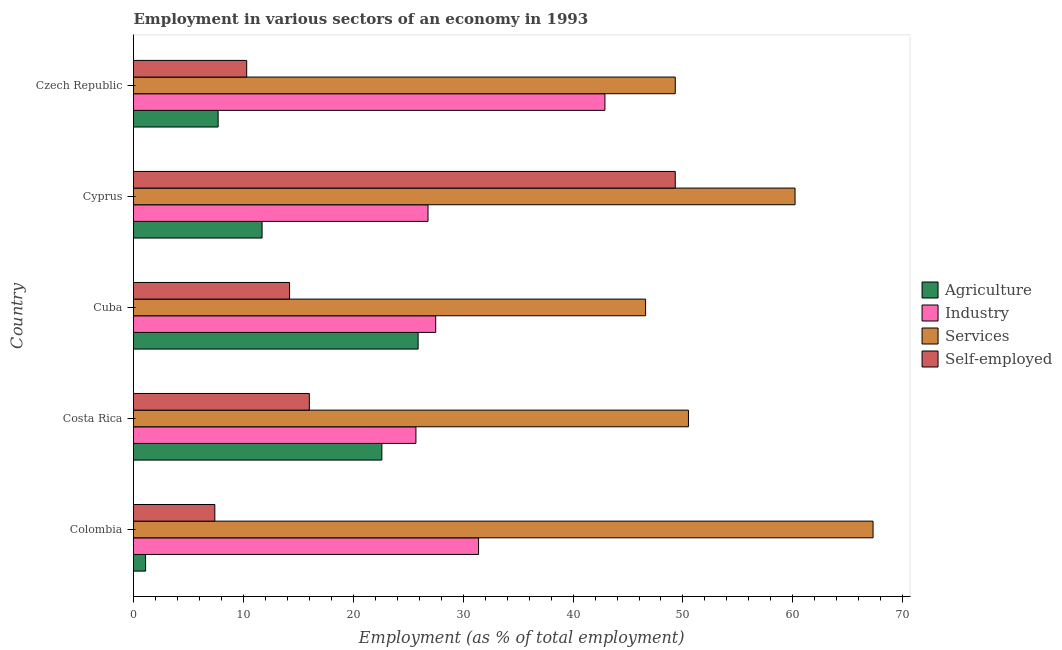How many different coloured bars are there?
Offer a very short reply. 4. Are the number of bars per tick equal to the number of legend labels?
Make the answer very short. Yes. Are the number of bars on each tick of the Y-axis equal?
Give a very brief answer. Yes. How many bars are there on the 3rd tick from the top?
Provide a short and direct response. 4. How many bars are there on the 2nd tick from the bottom?
Offer a terse response. 4. What is the label of the 3rd group of bars from the top?
Your response must be concise. Cuba. In how many cases, is the number of bars for a given country not equal to the number of legend labels?
Give a very brief answer. 0. What is the percentage of workers in services in Czech Republic?
Keep it short and to the point. 49.3. Across all countries, what is the maximum percentage of self employed workers?
Give a very brief answer. 49.3. Across all countries, what is the minimum percentage of workers in services?
Provide a short and direct response. 46.6. In which country was the percentage of workers in industry minimum?
Your response must be concise. Costa Rica. What is the total percentage of self employed workers in the graph?
Your answer should be very brief. 97.2. What is the difference between the percentage of self employed workers in Czech Republic and the percentage of workers in agriculture in Cyprus?
Your answer should be compact. -1.4. What is the average percentage of self employed workers per country?
Offer a terse response. 19.44. What is the difference between the percentage of self employed workers and percentage of workers in services in Cuba?
Make the answer very short. -32.4. What is the ratio of the percentage of workers in agriculture in Colombia to that in Czech Republic?
Offer a terse response. 0.14. Is the percentage of self employed workers in Cuba less than that in Czech Republic?
Offer a very short reply. No. What is the difference between the highest and the lowest percentage of workers in services?
Your answer should be compact. 20.7. In how many countries, is the percentage of workers in services greater than the average percentage of workers in services taken over all countries?
Provide a short and direct response. 2. Is the sum of the percentage of self employed workers in Colombia and Costa Rica greater than the maximum percentage of workers in industry across all countries?
Keep it short and to the point. No. What does the 2nd bar from the top in Czech Republic represents?
Ensure brevity in your answer.  Services. What does the 1st bar from the bottom in Cuba represents?
Make the answer very short. Agriculture. Is it the case that in every country, the sum of the percentage of workers in agriculture and percentage of workers in industry is greater than the percentage of workers in services?
Your answer should be compact. No. What is the difference between two consecutive major ticks on the X-axis?
Your answer should be very brief. 10. Where does the legend appear in the graph?
Offer a very short reply. Center right. What is the title of the graph?
Your answer should be very brief. Employment in various sectors of an economy in 1993. Does "Periodicity assessment" appear as one of the legend labels in the graph?
Provide a succinct answer. No. What is the label or title of the X-axis?
Give a very brief answer. Employment (as % of total employment). What is the label or title of the Y-axis?
Provide a short and direct response. Country. What is the Employment (as % of total employment) in Agriculture in Colombia?
Provide a short and direct response. 1.1. What is the Employment (as % of total employment) in Industry in Colombia?
Give a very brief answer. 31.4. What is the Employment (as % of total employment) in Services in Colombia?
Offer a very short reply. 67.3. What is the Employment (as % of total employment) of Self-employed in Colombia?
Provide a short and direct response. 7.4. What is the Employment (as % of total employment) in Agriculture in Costa Rica?
Your response must be concise. 22.6. What is the Employment (as % of total employment) of Industry in Costa Rica?
Keep it short and to the point. 25.7. What is the Employment (as % of total employment) in Services in Costa Rica?
Your answer should be very brief. 50.5. What is the Employment (as % of total employment) of Agriculture in Cuba?
Provide a short and direct response. 25.9. What is the Employment (as % of total employment) in Services in Cuba?
Offer a terse response. 46.6. What is the Employment (as % of total employment) of Self-employed in Cuba?
Ensure brevity in your answer.  14.2. What is the Employment (as % of total employment) of Agriculture in Cyprus?
Offer a terse response. 11.7. What is the Employment (as % of total employment) in Industry in Cyprus?
Provide a succinct answer. 26.8. What is the Employment (as % of total employment) in Services in Cyprus?
Make the answer very short. 60.2. What is the Employment (as % of total employment) in Self-employed in Cyprus?
Offer a terse response. 49.3. What is the Employment (as % of total employment) of Agriculture in Czech Republic?
Ensure brevity in your answer.  7.7. What is the Employment (as % of total employment) in Industry in Czech Republic?
Give a very brief answer. 42.9. What is the Employment (as % of total employment) in Services in Czech Republic?
Give a very brief answer. 49.3. What is the Employment (as % of total employment) in Self-employed in Czech Republic?
Make the answer very short. 10.3. Across all countries, what is the maximum Employment (as % of total employment) in Agriculture?
Ensure brevity in your answer.  25.9. Across all countries, what is the maximum Employment (as % of total employment) of Industry?
Provide a short and direct response. 42.9. Across all countries, what is the maximum Employment (as % of total employment) of Services?
Keep it short and to the point. 67.3. Across all countries, what is the maximum Employment (as % of total employment) of Self-employed?
Give a very brief answer. 49.3. Across all countries, what is the minimum Employment (as % of total employment) in Agriculture?
Ensure brevity in your answer.  1.1. Across all countries, what is the minimum Employment (as % of total employment) of Industry?
Your response must be concise. 25.7. Across all countries, what is the minimum Employment (as % of total employment) of Services?
Your answer should be compact. 46.6. Across all countries, what is the minimum Employment (as % of total employment) of Self-employed?
Your answer should be compact. 7.4. What is the total Employment (as % of total employment) in Industry in the graph?
Provide a succinct answer. 154.3. What is the total Employment (as % of total employment) in Services in the graph?
Ensure brevity in your answer.  273.9. What is the total Employment (as % of total employment) of Self-employed in the graph?
Provide a short and direct response. 97.2. What is the difference between the Employment (as % of total employment) of Agriculture in Colombia and that in Costa Rica?
Offer a very short reply. -21.5. What is the difference between the Employment (as % of total employment) in Services in Colombia and that in Costa Rica?
Keep it short and to the point. 16.8. What is the difference between the Employment (as % of total employment) of Agriculture in Colombia and that in Cuba?
Ensure brevity in your answer.  -24.8. What is the difference between the Employment (as % of total employment) of Services in Colombia and that in Cuba?
Ensure brevity in your answer.  20.7. What is the difference between the Employment (as % of total employment) of Agriculture in Colombia and that in Cyprus?
Your response must be concise. -10.6. What is the difference between the Employment (as % of total employment) of Services in Colombia and that in Cyprus?
Your answer should be compact. 7.1. What is the difference between the Employment (as % of total employment) of Self-employed in Colombia and that in Cyprus?
Your response must be concise. -41.9. What is the difference between the Employment (as % of total employment) in Agriculture in Colombia and that in Czech Republic?
Offer a very short reply. -6.6. What is the difference between the Employment (as % of total employment) of Industry in Colombia and that in Czech Republic?
Your answer should be very brief. -11.5. What is the difference between the Employment (as % of total employment) of Self-employed in Colombia and that in Czech Republic?
Ensure brevity in your answer.  -2.9. What is the difference between the Employment (as % of total employment) in Self-employed in Costa Rica and that in Cuba?
Give a very brief answer. 1.8. What is the difference between the Employment (as % of total employment) in Agriculture in Costa Rica and that in Cyprus?
Provide a short and direct response. 10.9. What is the difference between the Employment (as % of total employment) of Industry in Costa Rica and that in Cyprus?
Ensure brevity in your answer.  -1.1. What is the difference between the Employment (as % of total employment) of Self-employed in Costa Rica and that in Cyprus?
Make the answer very short. -33.3. What is the difference between the Employment (as % of total employment) of Industry in Costa Rica and that in Czech Republic?
Give a very brief answer. -17.2. What is the difference between the Employment (as % of total employment) of Services in Costa Rica and that in Czech Republic?
Provide a short and direct response. 1.2. What is the difference between the Employment (as % of total employment) of Agriculture in Cuba and that in Cyprus?
Offer a terse response. 14.2. What is the difference between the Employment (as % of total employment) in Self-employed in Cuba and that in Cyprus?
Provide a succinct answer. -35.1. What is the difference between the Employment (as % of total employment) of Industry in Cuba and that in Czech Republic?
Your answer should be very brief. -15.4. What is the difference between the Employment (as % of total employment) of Agriculture in Cyprus and that in Czech Republic?
Provide a short and direct response. 4. What is the difference between the Employment (as % of total employment) in Industry in Cyprus and that in Czech Republic?
Offer a terse response. -16.1. What is the difference between the Employment (as % of total employment) of Services in Cyprus and that in Czech Republic?
Provide a succinct answer. 10.9. What is the difference between the Employment (as % of total employment) in Self-employed in Cyprus and that in Czech Republic?
Your answer should be very brief. 39. What is the difference between the Employment (as % of total employment) in Agriculture in Colombia and the Employment (as % of total employment) in Industry in Costa Rica?
Offer a terse response. -24.6. What is the difference between the Employment (as % of total employment) of Agriculture in Colombia and the Employment (as % of total employment) of Services in Costa Rica?
Provide a short and direct response. -49.4. What is the difference between the Employment (as % of total employment) of Agriculture in Colombia and the Employment (as % of total employment) of Self-employed in Costa Rica?
Keep it short and to the point. -14.9. What is the difference between the Employment (as % of total employment) of Industry in Colombia and the Employment (as % of total employment) of Services in Costa Rica?
Keep it short and to the point. -19.1. What is the difference between the Employment (as % of total employment) in Services in Colombia and the Employment (as % of total employment) in Self-employed in Costa Rica?
Your response must be concise. 51.3. What is the difference between the Employment (as % of total employment) in Agriculture in Colombia and the Employment (as % of total employment) in Industry in Cuba?
Give a very brief answer. -26.4. What is the difference between the Employment (as % of total employment) in Agriculture in Colombia and the Employment (as % of total employment) in Services in Cuba?
Provide a succinct answer. -45.5. What is the difference between the Employment (as % of total employment) in Industry in Colombia and the Employment (as % of total employment) in Services in Cuba?
Ensure brevity in your answer.  -15.2. What is the difference between the Employment (as % of total employment) of Industry in Colombia and the Employment (as % of total employment) of Self-employed in Cuba?
Provide a succinct answer. 17.2. What is the difference between the Employment (as % of total employment) in Services in Colombia and the Employment (as % of total employment) in Self-employed in Cuba?
Your answer should be compact. 53.1. What is the difference between the Employment (as % of total employment) in Agriculture in Colombia and the Employment (as % of total employment) in Industry in Cyprus?
Your answer should be compact. -25.7. What is the difference between the Employment (as % of total employment) of Agriculture in Colombia and the Employment (as % of total employment) of Services in Cyprus?
Ensure brevity in your answer.  -59.1. What is the difference between the Employment (as % of total employment) in Agriculture in Colombia and the Employment (as % of total employment) in Self-employed in Cyprus?
Make the answer very short. -48.2. What is the difference between the Employment (as % of total employment) in Industry in Colombia and the Employment (as % of total employment) in Services in Cyprus?
Give a very brief answer. -28.8. What is the difference between the Employment (as % of total employment) in Industry in Colombia and the Employment (as % of total employment) in Self-employed in Cyprus?
Offer a terse response. -17.9. What is the difference between the Employment (as % of total employment) in Services in Colombia and the Employment (as % of total employment) in Self-employed in Cyprus?
Make the answer very short. 18. What is the difference between the Employment (as % of total employment) of Agriculture in Colombia and the Employment (as % of total employment) of Industry in Czech Republic?
Keep it short and to the point. -41.8. What is the difference between the Employment (as % of total employment) in Agriculture in Colombia and the Employment (as % of total employment) in Services in Czech Republic?
Your answer should be very brief. -48.2. What is the difference between the Employment (as % of total employment) of Agriculture in Colombia and the Employment (as % of total employment) of Self-employed in Czech Republic?
Ensure brevity in your answer.  -9.2. What is the difference between the Employment (as % of total employment) in Industry in Colombia and the Employment (as % of total employment) in Services in Czech Republic?
Provide a succinct answer. -17.9. What is the difference between the Employment (as % of total employment) in Industry in Colombia and the Employment (as % of total employment) in Self-employed in Czech Republic?
Offer a terse response. 21.1. What is the difference between the Employment (as % of total employment) in Industry in Costa Rica and the Employment (as % of total employment) in Services in Cuba?
Provide a short and direct response. -20.9. What is the difference between the Employment (as % of total employment) of Services in Costa Rica and the Employment (as % of total employment) of Self-employed in Cuba?
Keep it short and to the point. 36.3. What is the difference between the Employment (as % of total employment) of Agriculture in Costa Rica and the Employment (as % of total employment) of Services in Cyprus?
Your answer should be very brief. -37.6. What is the difference between the Employment (as % of total employment) in Agriculture in Costa Rica and the Employment (as % of total employment) in Self-employed in Cyprus?
Keep it short and to the point. -26.7. What is the difference between the Employment (as % of total employment) of Industry in Costa Rica and the Employment (as % of total employment) of Services in Cyprus?
Ensure brevity in your answer.  -34.5. What is the difference between the Employment (as % of total employment) in Industry in Costa Rica and the Employment (as % of total employment) in Self-employed in Cyprus?
Offer a very short reply. -23.6. What is the difference between the Employment (as % of total employment) in Services in Costa Rica and the Employment (as % of total employment) in Self-employed in Cyprus?
Keep it short and to the point. 1.2. What is the difference between the Employment (as % of total employment) of Agriculture in Costa Rica and the Employment (as % of total employment) of Industry in Czech Republic?
Provide a succinct answer. -20.3. What is the difference between the Employment (as % of total employment) in Agriculture in Costa Rica and the Employment (as % of total employment) in Services in Czech Republic?
Give a very brief answer. -26.7. What is the difference between the Employment (as % of total employment) in Industry in Costa Rica and the Employment (as % of total employment) in Services in Czech Republic?
Keep it short and to the point. -23.6. What is the difference between the Employment (as % of total employment) in Industry in Costa Rica and the Employment (as % of total employment) in Self-employed in Czech Republic?
Provide a succinct answer. 15.4. What is the difference between the Employment (as % of total employment) in Services in Costa Rica and the Employment (as % of total employment) in Self-employed in Czech Republic?
Provide a succinct answer. 40.2. What is the difference between the Employment (as % of total employment) in Agriculture in Cuba and the Employment (as % of total employment) in Services in Cyprus?
Provide a succinct answer. -34.3. What is the difference between the Employment (as % of total employment) of Agriculture in Cuba and the Employment (as % of total employment) of Self-employed in Cyprus?
Provide a short and direct response. -23.4. What is the difference between the Employment (as % of total employment) in Industry in Cuba and the Employment (as % of total employment) in Services in Cyprus?
Ensure brevity in your answer.  -32.7. What is the difference between the Employment (as % of total employment) of Industry in Cuba and the Employment (as % of total employment) of Self-employed in Cyprus?
Your response must be concise. -21.8. What is the difference between the Employment (as % of total employment) of Agriculture in Cuba and the Employment (as % of total employment) of Industry in Czech Republic?
Your answer should be compact. -17. What is the difference between the Employment (as % of total employment) of Agriculture in Cuba and the Employment (as % of total employment) of Services in Czech Republic?
Offer a terse response. -23.4. What is the difference between the Employment (as % of total employment) of Industry in Cuba and the Employment (as % of total employment) of Services in Czech Republic?
Your response must be concise. -21.8. What is the difference between the Employment (as % of total employment) of Services in Cuba and the Employment (as % of total employment) of Self-employed in Czech Republic?
Offer a terse response. 36.3. What is the difference between the Employment (as % of total employment) of Agriculture in Cyprus and the Employment (as % of total employment) of Industry in Czech Republic?
Give a very brief answer. -31.2. What is the difference between the Employment (as % of total employment) in Agriculture in Cyprus and the Employment (as % of total employment) in Services in Czech Republic?
Ensure brevity in your answer.  -37.6. What is the difference between the Employment (as % of total employment) of Agriculture in Cyprus and the Employment (as % of total employment) of Self-employed in Czech Republic?
Provide a succinct answer. 1.4. What is the difference between the Employment (as % of total employment) in Industry in Cyprus and the Employment (as % of total employment) in Services in Czech Republic?
Your response must be concise. -22.5. What is the difference between the Employment (as % of total employment) in Services in Cyprus and the Employment (as % of total employment) in Self-employed in Czech Republic?
Your response must be concise. 49.9. What is the average Employment (as % of total employment) of Agriculture per country?
Ensure brevity in your answer.  13.8. What is the average Employment (as % of total employment) of Industry per country?
Provide a succinct answer. 30.86. What is the average Employment (as % of total employment) of Services per country?
Offer a terse response. 54.78. What is the average Employment (as % of total employment) in Self-employed per country?
Provide a short and direct response. 19.44. What is the difference between the Employment (as % of total employment) in Agriculture and Employment (as % of total employment) in Industry in Colombia?
Offer a very short reply. -30.3. What is the difference between the Employment (as % of total employment) in Agriculture and Employment (as % of total employment) in Services in Colombia?
Your answer should be compact. -66.2. What is the difference between the Employment (as % of total employment) in Agriculture and Employment (as % of total employment) in Self-employed in Colombia?
Keep it short and to the point. -6.3. What is the difference between the Employment (as % of total employment) of Industry and Employment (as % of total employment) of Services in Colombia?
Keep it short and to the point. -35.9. What is the difference between the Employment (as % of total employment) of Services and Employment (as % of total employment) of Self-employed in Colombia?
Make the answer very short. 59.9. What is the difference between the Employment (as % of total employment) of Agriculture and Employment (as % of total employment) of Industry in Costa Rica?
Your response must be concise. -3.1. What is the difference between the Employment (as % of total employment) in Agriculture and Employment (as % of total employment) in Services in Costa Rica?
Offer a very short reply. -27.9. What is the difference between the Employment (as % of total employment) of Agriculture and Employment (as % of total employment) of Self-employed in Costa Rica?
Your answer should be compact. 6.6. What is the difference between the Employment (as % of total employment) of Industry and Employment (as % of total employment) of Services in Costa Rica?
Your answer should be very brief. -24.8. What is the difference between the Employment (as % of total employment) in Services and Employment (as % of total employment) in Self-employed in Costa Rica?
Your response must be concise. 34.5. What is the difference between the Employment (as % of total employment) of Agriculture and Employment (as % of total employment) of Services in Cuba?
Offer a very short reply. -20.7. What is the difference between the Employment (as % of total employment) of Agriculture and Employment (as % of total employment) of Self-employed in Cuba?
Your response must be concise. 11.7. What is the difference between the Employment (as % of total employment) of Industry and Employment (as % of total employment) of Services in Cuba?
Offer a very short reply. -19.1. What is the difference between the Employment (as % of total employment) of Industry and Employment (as % of total employment) of Self-employed in Cuba?
Ensure brevity in your answer.  13.3. What is the difference between the Employment (as % of total employment) of Services and Employment (as % of total employment) of Self-employed in Cuba?
Your answer should be compact. 32.4. What is the difference between the Employment (as % of total employment) in Agriculture and Employment (as % of total employment) in Industry in Cyprus?
Your answer should be compact. -15.1. What is the difference between the Employment (as % of total employment) of Agriculture and Employment (as % of total employment) of Services in Cyprus?
Your answer should be compact. -48.5. What is the difference between the Employment (as % of total employment) of Agriculture and Employment (as % of total employment) of Self-employed in Cyprus?
Ensure brevity in your answer.  -37.6. What is the difference between the Employment (as % of total employment) in Industry and Employment (as % of total employment) in Services in Cyprus?
Your response must be concise. -33.4. What is the difference between the Employment (as % of total employment) in Industry and Employment (as % of total employment) in Self-employed in Cyprus?
Provide a short and direct response. -22.5. What is the difference between the Employment (as % of total employment) in Services and Employment (as % of total employment) in Self-employed in Cyprus?
Keep it short and to the point. 10.9. What is the difference between the Employment (as % of total employment) of Agriculture and Employment (as % of total employment) of Industry in Czech Republic?
Keep it short and to the point. -35.2. What is the difference between the Employment (as % of total employment) of Agriculture and Employment (as % of total employment) of Services in Czech Republic?
Your answer should be compact. -41.6. What is the difference between the Employment (as % of total employment) of Industry and Employment (as % of total employment) of Services in Czech Republic?
Provide a short and direct response. -6.4. What is the difference between the Employment (as % of total employment) of Industry and Employment (as % of total employment) of Self-employed in Czech Republic?
Provide a short and direct response. 32.6. What is the ratio of the Employment (as % of total employment) in Agriculture in Colombia to that in Costa Rica?
Give a very brief answer. 0.05. What is the ratio of the Employment (as % of total employment) of Industry in Colombia to that in Costa Rica?
Offer a terse response. 1.22. What is the ratio of the Employment (as % of total employment) of Services in Colombia to that in Costa Rica?
Offer a very short reply. 1.33. What is the ratio of the Employment (as % of total employment) of Self-employed in Colombia to that in Costa Rica?
Provide a succinct answer. 0.46. What is the ratio of the Employment (as % of total employment) in Agriculture in Colombia to that in Cuba?
Your answer should be compact. 0.04. What is the ratio of the Employment (as % of total employment) in Industry in Colombia to that in Cuba?
Provide a succinct answer. 1.14. What is the ratio of the Employment (as % of total employment) of Services in Colombia to that in Cuba?
Your answer should be compact. 1.44. What is the ratio of the Employment (as % of total employment) of Self-employed in Colombia to that in Cuba?
Ensure brevity in your answer.  0.52. What is the ratio of the Employment (as % of total employment) in Agriculture in Colombia to that in Cyprus?
Offer a terse response. 0.09. What is the ratio of the Employment (as % of total employment) in Industry in Colombia to that in Cyprus?
Give a very brief answer. 1.17. What is the ratio of the Employment (as % of total employment) in Services in Colombia to that in Cyprus?
Offer a terse response. 1.12. What is the ratio of the Employment (as % of total employment) of Self-employed in Colombia to that in Cyprus?
Your answer should be very brief. 0.15. What is the ratio of the Employment (as % of total employment) of Agriculture in Colombia to that in Czech Republic?
Your answer should be very brief. 0.14. What is the ratio of the Employment (as % of total employment) of Industry in Colombia to that in Czech Republic?
Offer a terse response. 0.73. What is the ratio of the Employment (as % of total employment) of Services in Colombia to that in Czech Republic?
Provide a succinct answer. 1.37. What is the ratio of the Employment (as % of total employment) of Self-employed in Colombia to that in Czech Republic?
Offer a terse response. 0.72. What is the ratio of the Employment (as % of total employment) in Agriculture in Costa Rica to that in Cuba?
Keep it short and to the point. 0.87. What is the ratio of the Employment (as % of total employment) of Industry in Costa Rica to that in Cuba?
Your answer should be very brief. 0.93. What is the ratio of the Employment (as % of total employment) in Services in Costa Rica to that in Cuba?
Your answer should be very brief. 1.08. What is the ratio of the Employment (as % of total employment) in Self-employed in Costa Rica to that in Cuba?
Provide a short and direct response. 1.13. What is the ratio of the Employment (as % of total employment) in Agriculture in Costa Rica to that in Cyprus?
Ensure brevity in your answer.  1.93. What is the ratio of the Employment (as % of total employment) in Services in Costa Rica to that in Cyprus?
Offer a very short reply. 0.84. What is the ratio of the Employment (as % of total employment) of Self-employed in Costa Rica to that in Cyprus?
Make the answer very short. 0.32. What is the ratio of the Employment (as % of total employment) in Agriculture in Costa Rica to that in Czech Republic?
Keep it short and to the point. 2.94. What is the ratio of the Employment (as % of total employment) of Industry in Costa Rica to that in Czech Republic?
Offer a terse response. 0.6. What is the ratio of the Employment (as % of total employment) in Services in Costa Rica to that in Czech Republic?
Your response must be concise. 1.02. What is the ratio of the Employment (as % of total employment) of Self-employed in Costa Rica to that in Czech Republic?
Offer a very short reply. 1.55. What is the ratio of the Employment (as % of total employment) in Agriculture in Cuba to that in Cyprus?
Your answer should be very brief. 2.21. What is the ratio of the Employment (as % of total employment) of Industry in Cuba to that in Cyprus?
Ensure brevity in your answer.  1.03. What is the ratio of the Employment (as % of total employment) of Services in Cuba to that in Cyprus?
Keep it short and to the point. 0.77. What is the ratio of the Employment (as % of total employment) of Self-employed in Cuba to that in Cyprus?
Offer a very short reply. 0.29. What is the ratio of the Employment (as % of total employment) in Agriculture in Cuba to that in Czech Republic?
Offer a terse response. 3.36. What is the ratio of the Employment (as % of total employment) of Industry in Cuba to that in Czech Republic?
Your answer should be compact. 0.64. What is the ratio of the Employment (as % of total employment) in Services in Cuba to that in Czech Republic?
Make the answer very short. 0.95. What is the ratio of the Employment (as % of total employment) in Self-employed in Cuba to that in Czech Republic?
Give a very brief answer. 1.38. What is the ratio of the Employment (as % of total employment) in Agriculture in Cyprus to that in Czech Republic?
Provide a succinct answer. 1.52. What is the ratio of the Employment (as % of total employment) of Industry in Cyprus to that in Czech Republic?
Your answer should be compact. 0.62. What is the ratio of the Employment (as % of total employment) of Services in Cyprus to that in Czech Republic?
Offer a terse response. 1.22. What is the ratio of the Employment (as % of total employment) in Self-employed in Cyprus to that in Czech Republic?
Provide a short and direct response. 4.79. What is the difference between the highest and the second highest Employment (as % of total employment) in Self-employed?
Your response must be concise. 33.3. What is the difference between the highest and the lowest Employment (as % of total employment) in Agriculture?
Provide a succinct answer. 24.8. What is the difference between the highest and the lowest Employment (as % of total employment) in Services?
Your response must be concise. 20.7. What is the difference between the highest and the lowest Employment (as % of total employment) of Self-employed?
Offer a terse response. 41.9. 